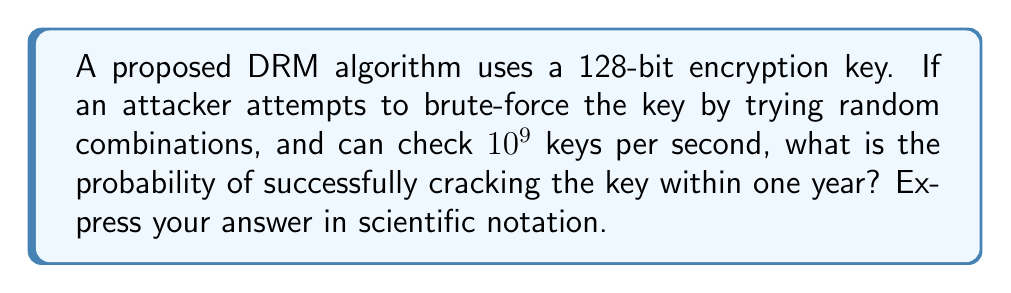Solve this math problem. Let's approach this step-by-step:

1) First, we need to calculate the total number of possible keys:
   With a 128-bit key, there are $2^{128}$ possible combinations.

2) Next, let's calculate how many keys the attacker can check in one year:
   Keys per second: $10^9$
   Seconds in a year: $365 \times 24 \times 60 \times 60 = 31,536,000$
   Keys checked in a year: $10^9 \times 31,536,000 = 3.1536 \times 10^{16}$

3) Now, we can calculate the probability of success:
   Probability = (Number of favorable outcomes) / (Total number of possible outcomes)
   $$ P(\text{success}) = \frac{3.1536 \times 10^{16}}{2^{128}} $$

4) Let's simplify this:
   $2^{128} \approx 3.4028 \times 10^{38}$
   
   $$ P(\text{success}) = \frac{3.1536 \times 10^{16}}{3.4028 \times 10^{38}} \approx 9.2676 \times 10^{-23} $$

5) This probability is extremely low, demonstrating the strength of a 128-bit encryption key against brute-force attacks.
Answer: $9.27 \times 10^{-23}$ 